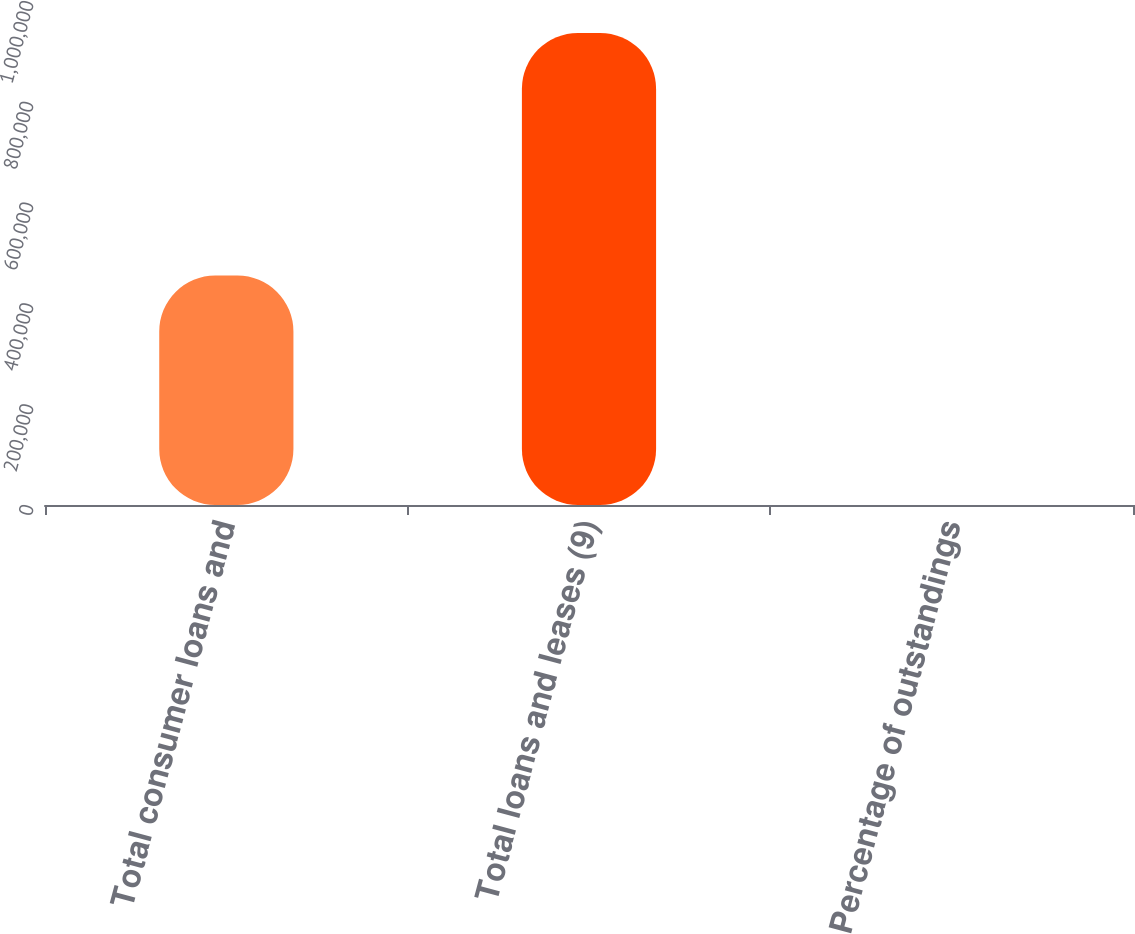Convert chart to OTSL. <chart><loc_0><loc_0><loc_500><loc_500><bar_chart><fcel>Total consumer loans and<fcel>Total loans and leases (9)<fcel>Percentage of outstandings<nl><fcel>455276<fcel>936749<fcel>100<nl></chart> 